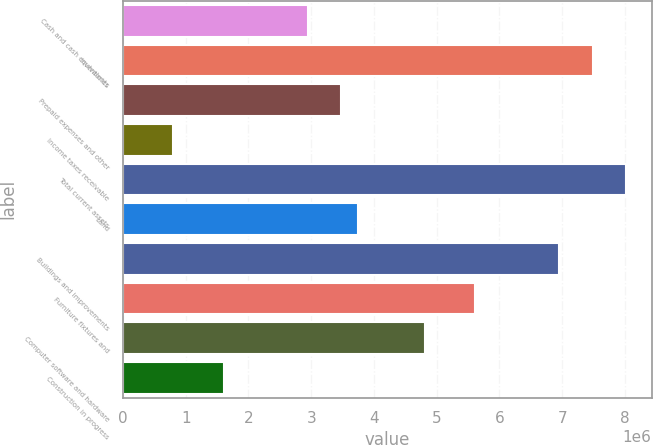<chart> <loc_0><loc_0><loc_500><loc_500><bar_chart><fcel>Cash and cash equivalents<fcel>Inventories<fcel>Prepaid expenses and other<fcel>Income taxes receivable<fcel>Total current assets<fcel>Land<fcel>Buildings and improvements<fcel>Furniture fixtures and<fcel>Computer software and hardware<fcel>Construction in progress<nl><fcel>2.94231e+06<fcel>7.48751e+06<fcel>3.47704e+06<fcel>803388<fcel>8.02224e+06<fcel>3.7444e+06<fcel>6.95278e+06<fcel>5.61595e+06<fcel>4.81386e+06<fcel>1.60548e+06<nl></chart> 